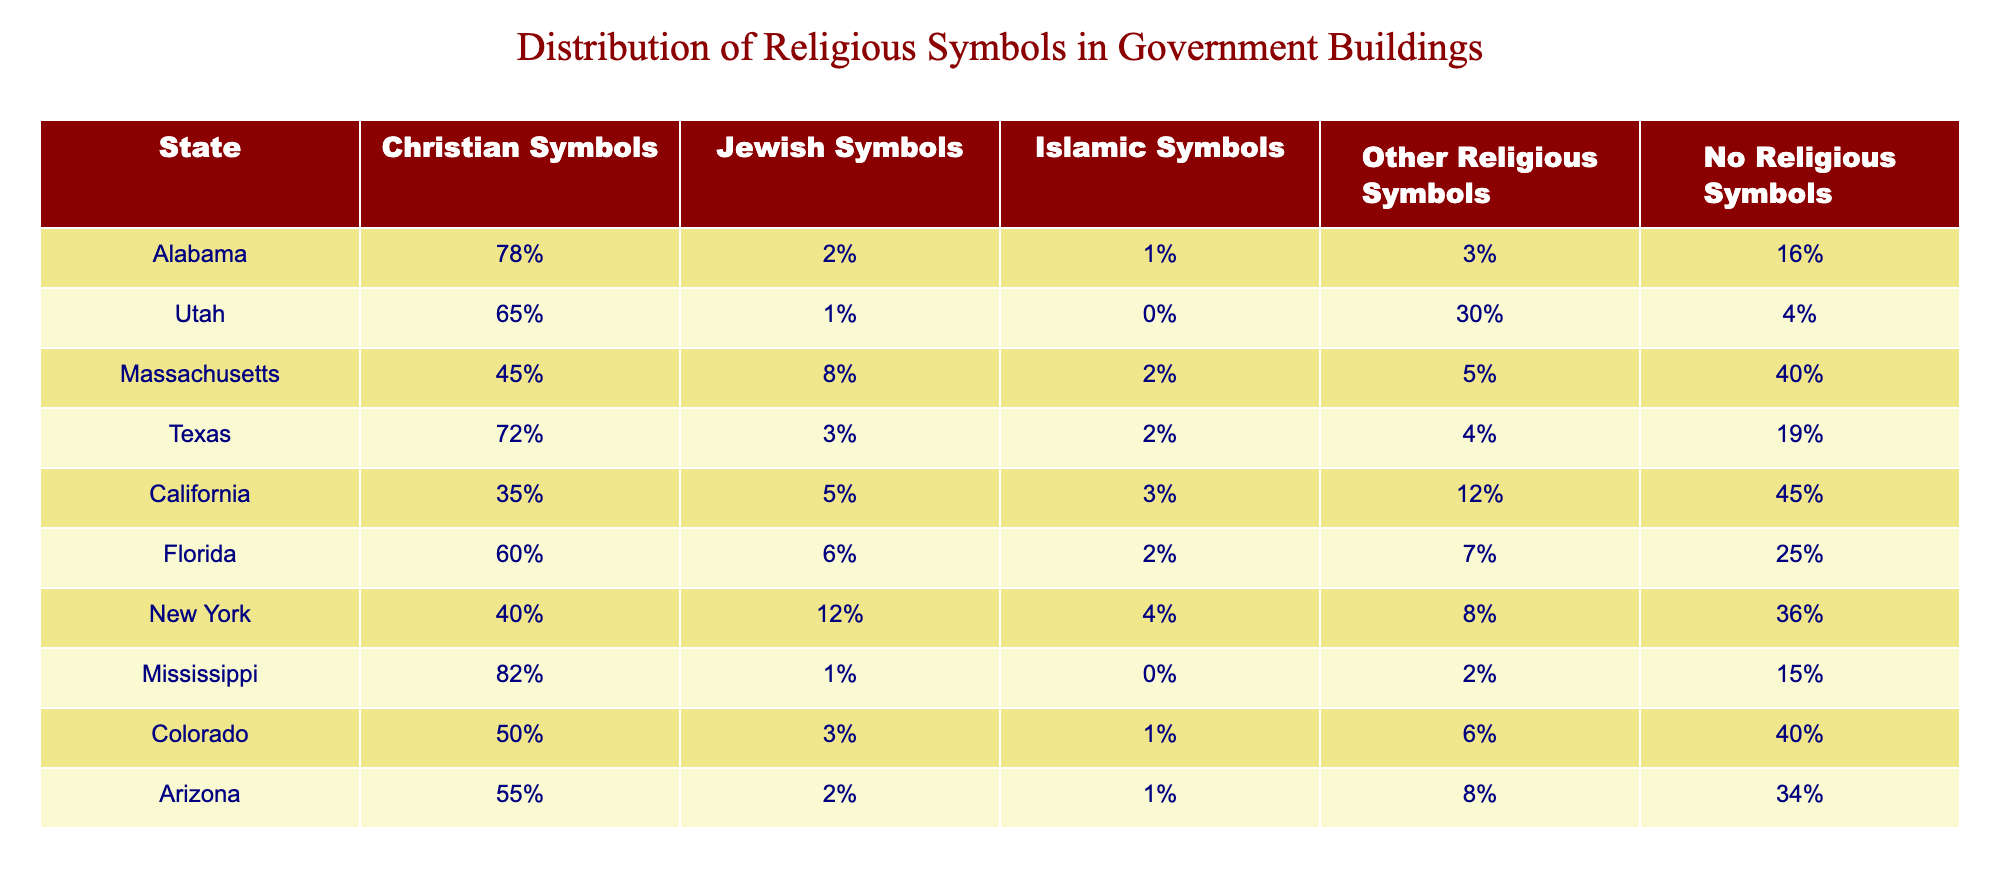What state has the highest percentage of Christian symbols in government buildings? By examining the table, we can see that Mississippi has the highest percentage at 82%.
Answer: Mississippi Which state has the lowest representation of Islamic symbols? Looking at the table, Utah has 0% representation of Islamic symbols in government buildings.
Answer: Utah What is the average percentage of Jewish symbols across all states? To find the average, we sum the percentages: (2 + 1 + 8 + 3 + 5 + 6 + 12 + 1 + 3 + 2) = 43%. There are 10 states, so the average is 43% / 10 = 4.3%.
Answer: 4.3% Are there any states with no religious symbols? Referring to the table, each state has at least some religious symbols, so the answer is no.
Answer: No Which state has the highest percentage of "Other Religious Symbols"? From the table, Utah has the highest percentage at 30%.
Answer: Utah What is the percentage difference of Christian symbols between Alabama and Florida? Alabama has 78% and Florida has 60%. The difference is 78% - 60% = 18%.
Answer: 18% List the states that have more than 40% of no religious symbols. California (45%), Massachusetts (40%), and New York (36%) have more than 40%, but we only consider California and Florida as above 40% since NY has 36%.
Answer: California, Florida What percentage of symbols in government buildings are Christian in Texas compared to California? Texas has 72% Christian symbols, while California has 35%. The difference is 72% - 35% = 37%.
Answer: 37% Which state has a higher percentage of no religious symbols, Massachusetts or Arizona? Massachusetts has 40% no religious symbols, while Arizona has 34%. Since 40% is greater than 34%, Massachusetts has a higher percentage.
Answer: Massachusetts 